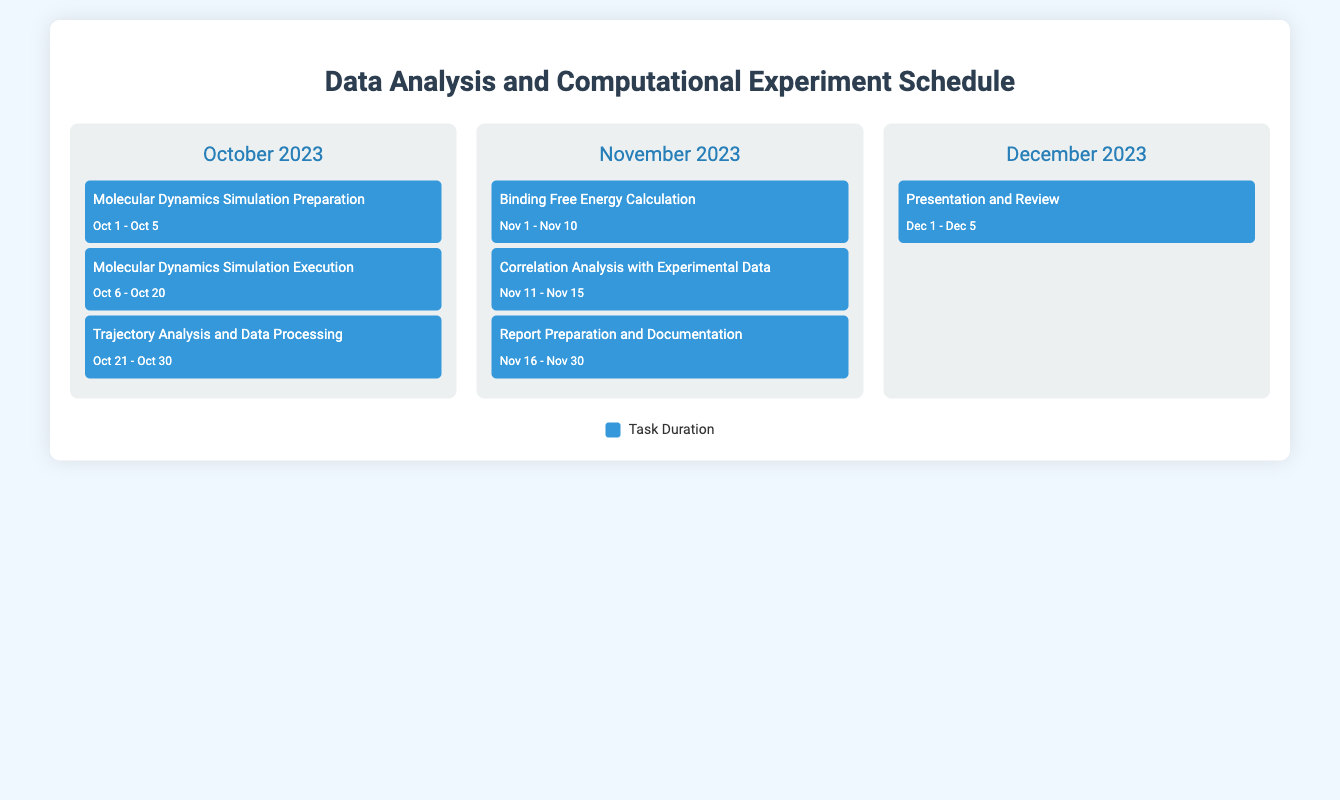What is the duration of the Molecular Dynamics Simulation Execution? The duration is specified as the period from Oct 6 to Oct 20 in the document.
Answer: Oct 6 - Oct 20 What task is scheduled for November 16 to November 30? The task for this period is Report Preparation and Documentation, as outlined in the calendar.
Answer: Report Preparation and Documentation How many days is the Trajectory Analysis and Data Processing scheduled for? The task spans from Oct 21 to Oct 30, which covers a total of 10 days.
Answer: 10 days What is the first task to be performed in December 2023? The document lists the first task as Presentation and Review, scheduled from Dec 1 to Dec 5.
Answer: Presentation and Review Which month features the Binding Free Energy Calculation? The task is scheduled for November 2023 as seen in the document's calendar.
Answer: November 2023 